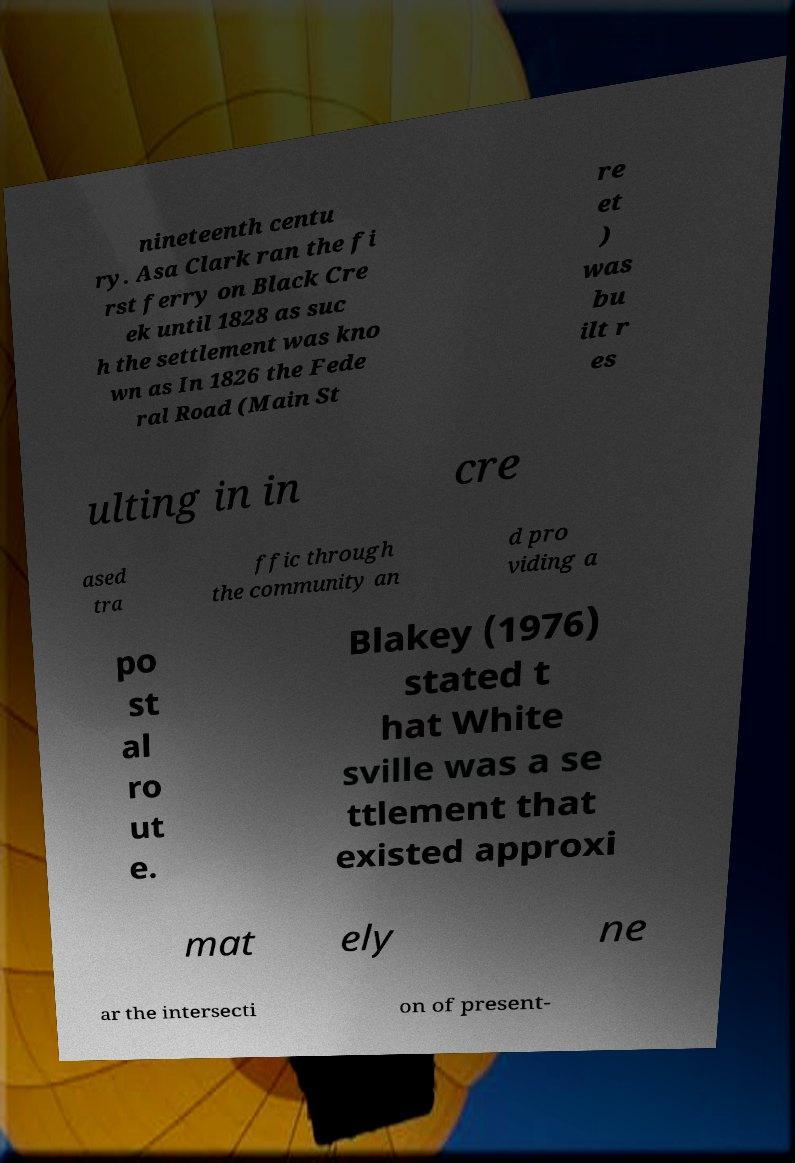Can you read and provide the text displayed in the image?This photo seems to have some interesting text. Can you extract and type it out for me? nineteenth centu ry. Asa Clark ran the fi rst ferry on Black Cre ek until 1828 as suc h the settlement was kno wn as In 1826 the Fede ral Road (Main St re et ) was bu ilt r es ulting in in cre ased tra ffic through the community an d pro viding a po st al ro ut e. Blakey (1976) stated t hat White sville was a se ttlement that existed approxi mat ely ne ar the intersecti on of present- 